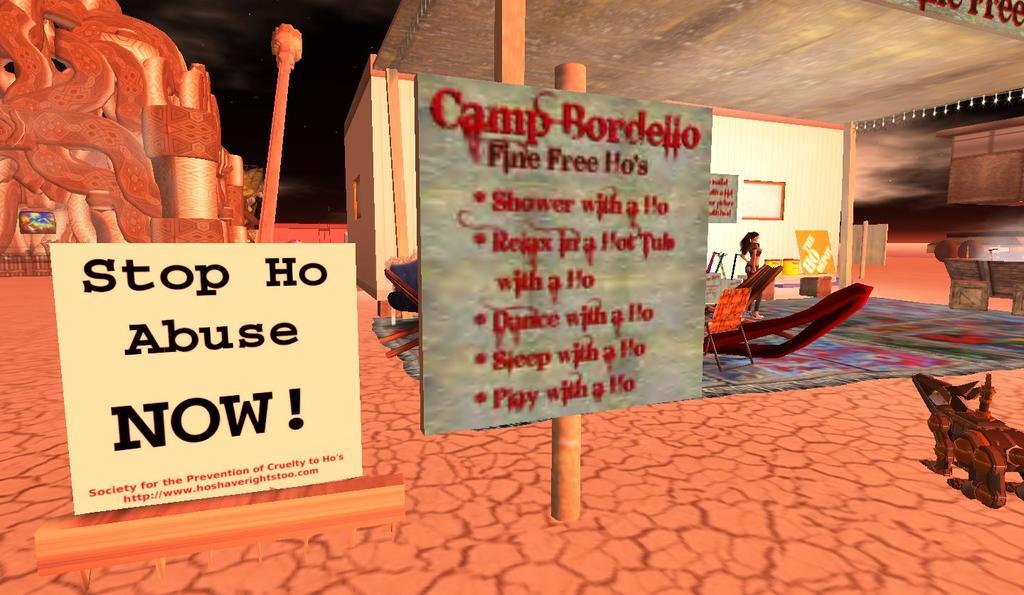What camp is mentioned on the sign board?
Make the answer very short. Bordello. What do they want to stop?
Give a very brief answer. Ho abuse. 